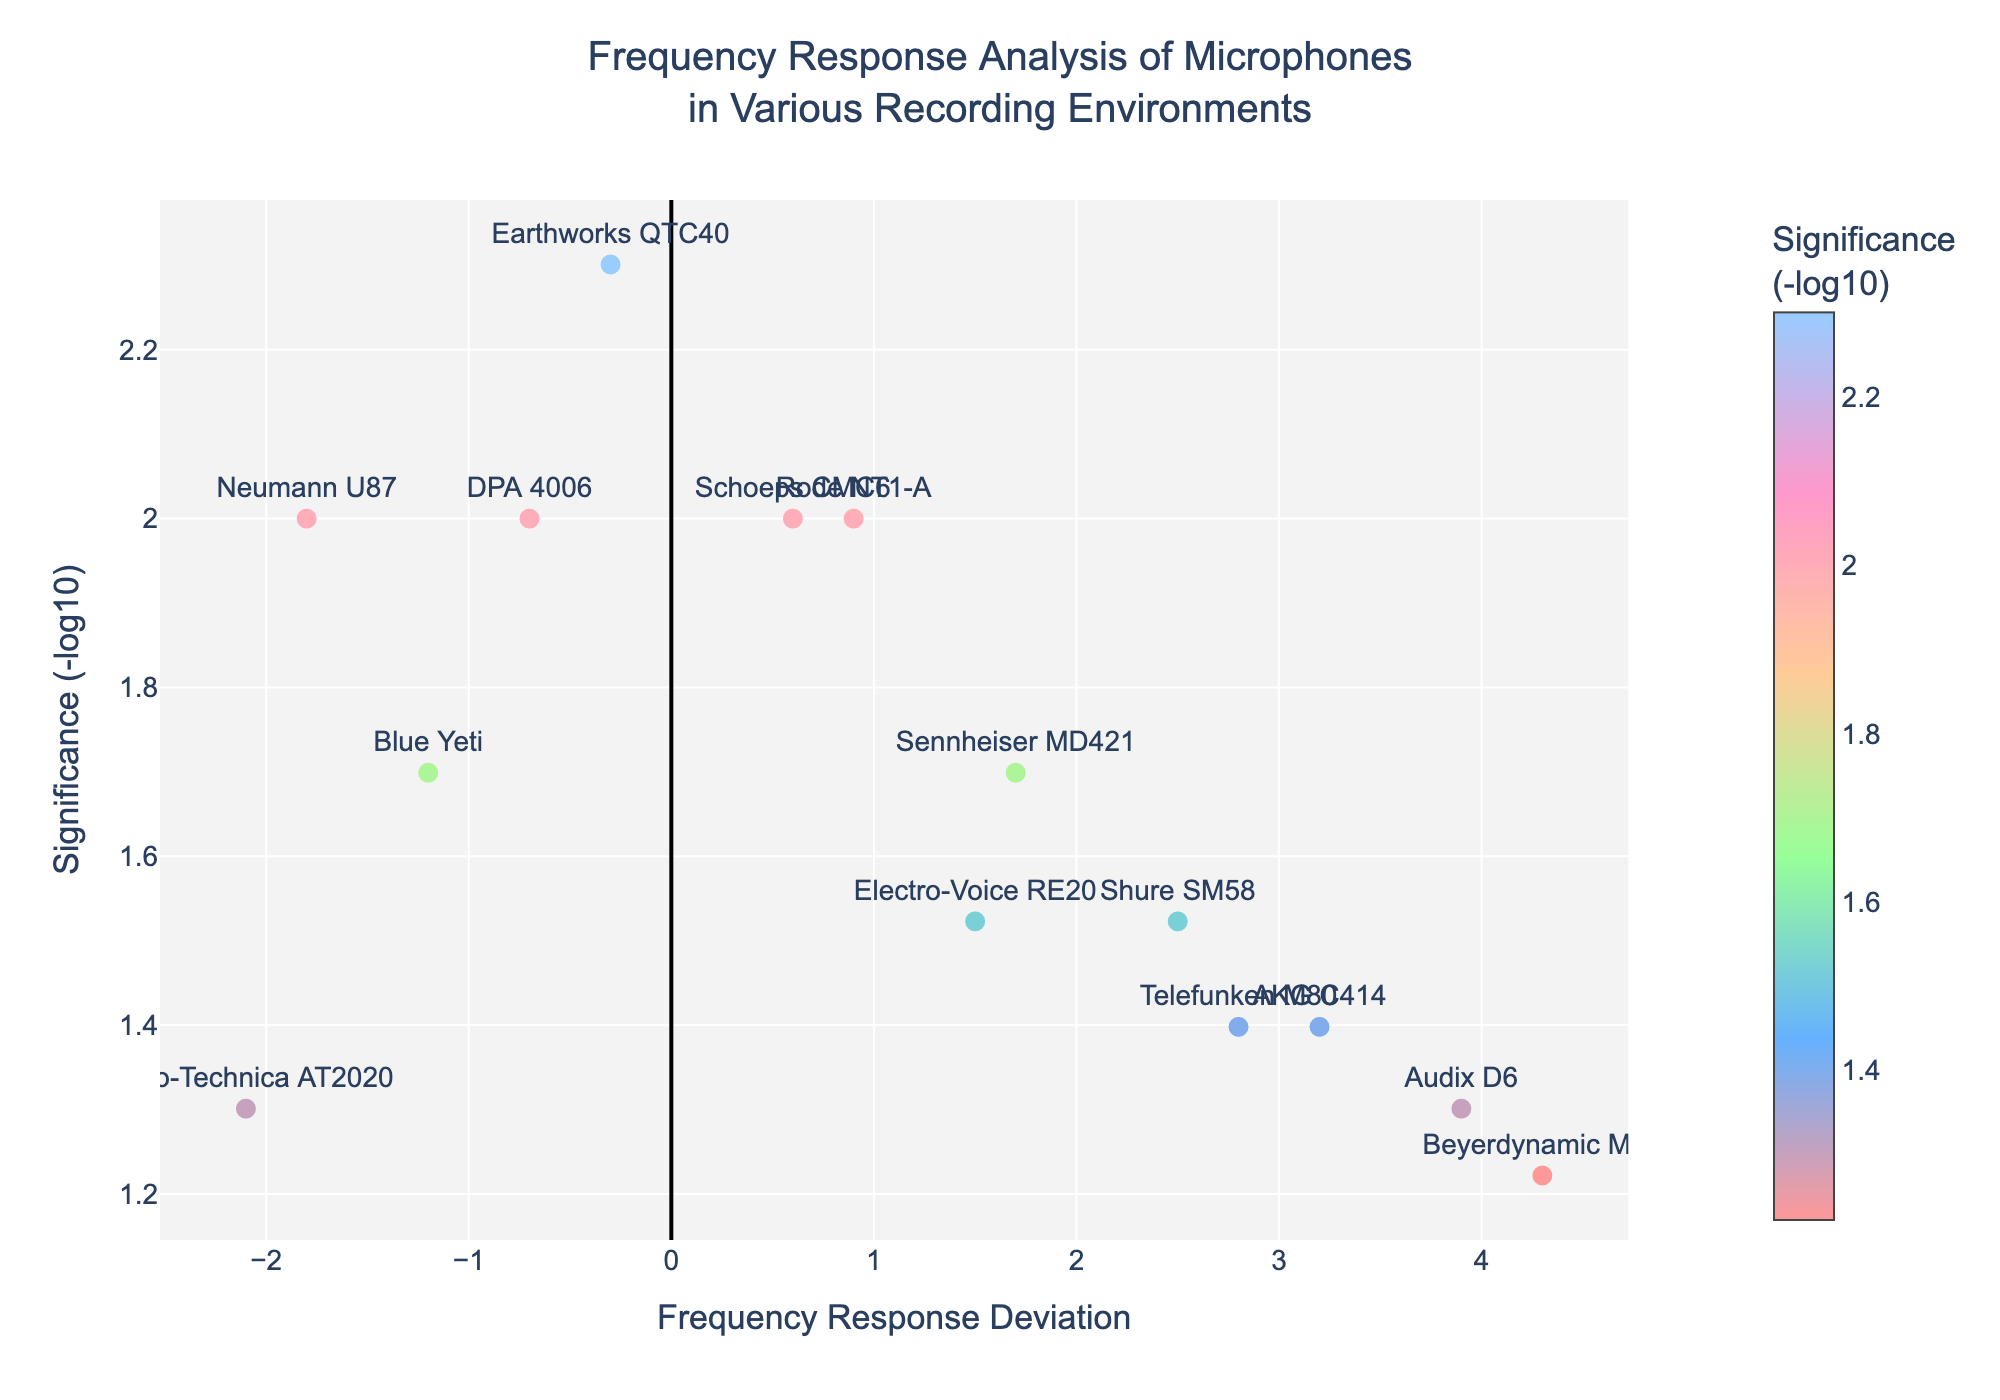what is the title of the plot? The title is located at the top of the plot. It provides a brief description of the content. The title reads "Frequency Response Analysis of Microphones\nin Various Recording Environments."
Answer: Frequency Response Analysis of Microphones\nin Various Recording Environments How many data points are there in the plot? Count the number of markers on the plot. Each marker represents a data point. There are 14 markers.
Answer: 14 Which microphone type shows the highest frequency response deviation? Look at the x-axis (Frequency Response Deviation) to find the data point that is farthest to the right. The highest deviation is 4.3, which corresponds to the Beyerdynamic M88 microphone.
Answer: Beyerdynamic M88 What is the environment for the microphone with the least significant frequency response deviation? Find the data point with the highest p-value or lowest negative logarithm of significance. The lowest significance (highest p-value) is 0.06, which corresponds to the Beyerdynamic M88 in the Outdoor event environment.
Answer: Outdoor event Which microphone has the most significant frequency response deviation in the Anechoic chamber environment, and what is the significance value? Find the data point labeled "Earthworks QTC40". The significance is shown on the y-axis. The marker is slightly above 3, so the significance value is approximately -log10(0.005).
Answer: Earthworks QTC40, 3 What is the difference in frequency response deviation between the Neumann U87 and the Audix D6? Find the x-axis values for Neumann U87 (-1.8) and Audix D6 (3.9), then calculate the difference: 3.9 - (-1.8) = 3.9 + 1.8.
Answer: 5.7 Which microphone has a frequency response deviation closest to zero, and what is the significance level? Look at the data points nearest to zero on the x-axis. The Earthworks QTC40 has the closest frequency response deviation to zero at -0.3. Its significance is approximately -log10(0.005).
Answer: Earthworks QTC40, -log10(0.005) What is the median frequency response deviation in the plot? To find the median, list the frequency response deviations in order: -2.1, -1.8, -1.2, -0.7, -0.3, 0.6, 0.9, 1.5, 1.7, 2.5, 2.8, 3.2, 3.9, 4.3. The median is the average of the 7th and 8th numbers since there are 14 values: (0.9 + 1.5) / 2.
Answer: 1.2 Which microphone type has the highest significance level, and what is its frequency response deviation? Find the highest y-axis value, which corresponds to the most significant level. This is the Earthworks QTC40 at approximately 3. The frequency response deviation for the QTC40 is -0.3.
Answer: Earthworks QTC40, -0.3 